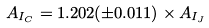Convert formula to latex. <formula><loc_0><loc_0><loc_500><loc_500>A _ { I _ { C } } = 1 . 2 0 2 ( \pm 0 . 0 1 1 ) \times A _ { I _ { J } }</formula> 